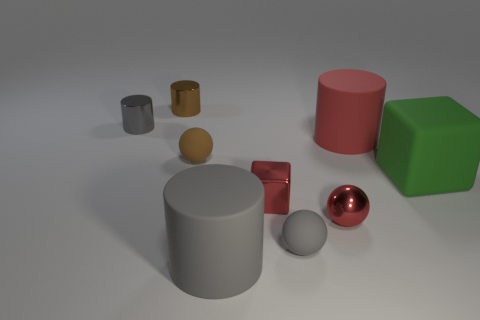Subtract 1 cylinders. How many cylinders are left? 3 Subtract all blue cubes. Subtract all green spheres. How many cubes are left? 2 Subtract all spheres. How many objects are left? 6 Add 6 large gray cylinders. How many large gray cylinders exist? 7 Subtract 1 gray spheres. How many objects are left? 8 Subtract all tiny yellow spheres. Subtract all balls. How many objects are left? 6 Add 4 green matte objects. How many green matte objects are left? 5 